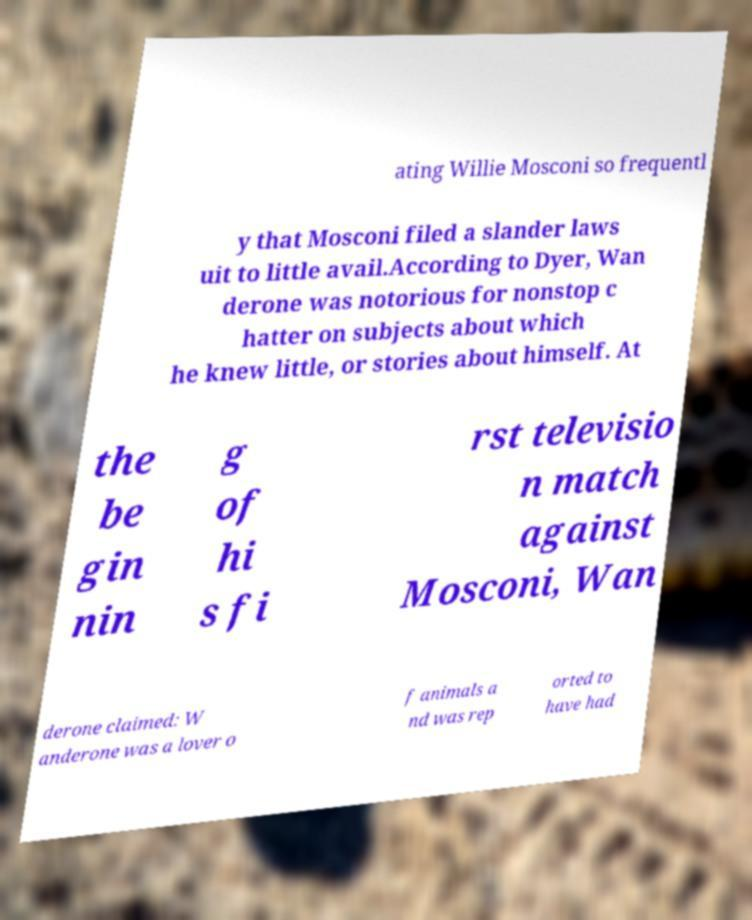Could you assist in decoding the text presented in this image and type it out clearly? ating Willie Mosconi so frequentl y that Mosconi filed a slander laws uit to little avail.According to Dyer, Wan derone was notorious for nonstop c hatter on subjects about which he knew little, or stories about himself. At the be gin nin g of hi s fi rst televisio n match against Mosconi, Wan derone claimed: W anderone was a lover o f animals a nd was rep orted to have had 